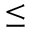Convert formula to latex. <formula><loc_0><loc_0><loc_500><loc_500>\leq</formula> 